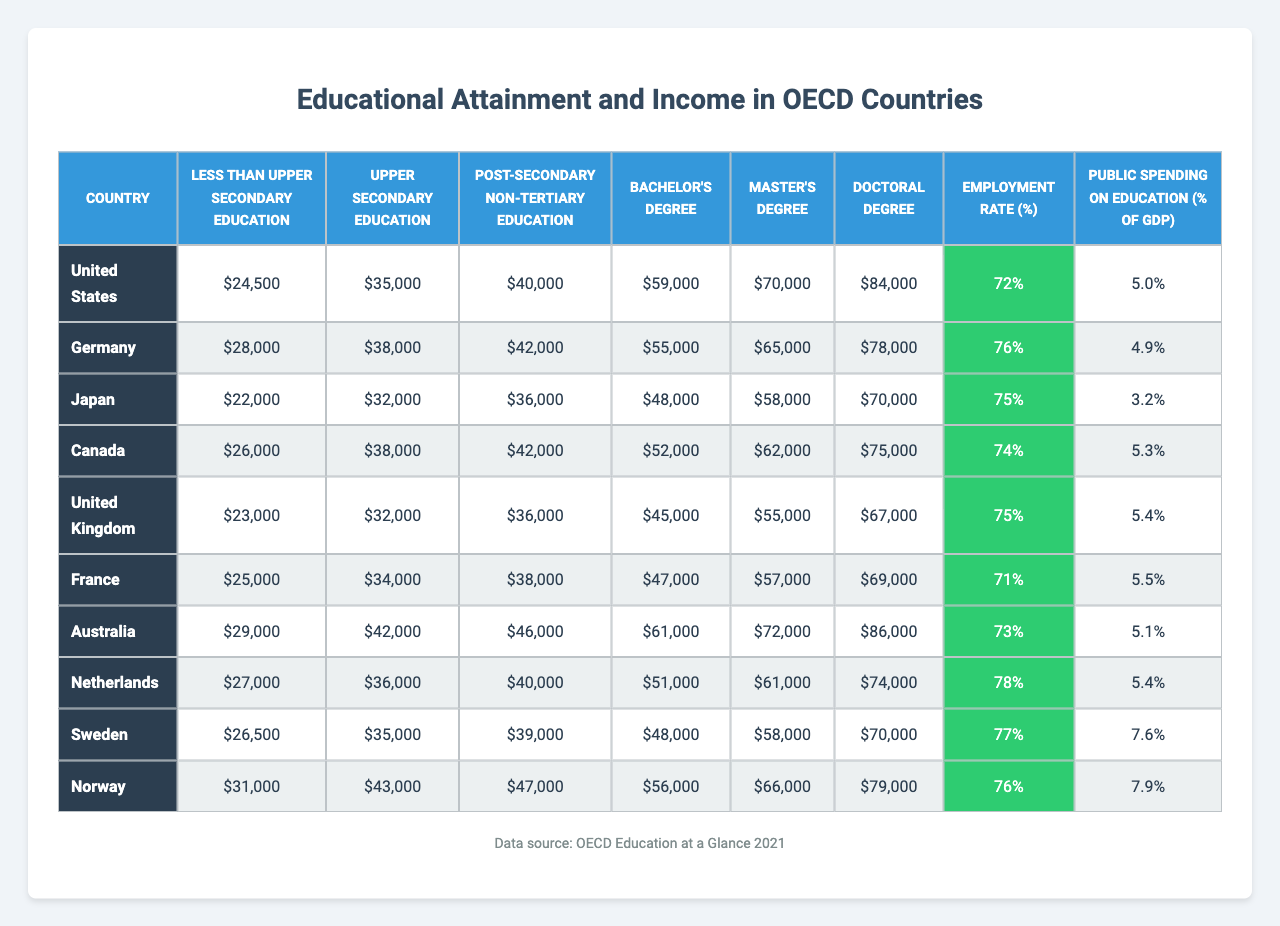What is the income for a person with a Bachelor's degree in Canada? According to the table, the income for a Bachelor's degree holder in Canada is specified as $52,000.
Answer: $52,000 Which country has the highest income for those with a Master's degree? From the table, Australia has the highest income for a Master's degree at $72,000, compared to others listed.
Answer: Australia - $72,000 What is the employment rate for the country with the least public spending on education? The country with the least public spending on education is Japan at 3.2%. The corresponding employment rate for Japan is 75%.
Answer: 75% How does the income for less than upper secondary education in the United States compare to that in Germany? The income in the United States is $24,500 and in Germany, it is $28,000. The difference is $28,000 - $24,500 = $3,500, indicating Germany has a higher income by that amount.
Answer: Germany is higher by $3,500 What is the average income for individuals with a Doctoral degree across all listed countries? To find the average, add the Doctoral degree incomes: (84,000 + 78,000 + 70,000 + 75,000 + 67,000 + 69,000 + 86,000 + 74,000 + 70,000 + 79,000) =  1,068,000, and divide by 10. The average income is $106,800 / 10 = $106,800.
Answer: $106,800 Which educational attainment level has the highest income in Sweden? The highest income in Sweden is for individuals with a Master's degree, which is $58,000.
Answer: Master's degree - $58,000 Is the employment rate higher for people with a Bachelor's degree compared to those with a Post-secondary non-tertiary education in Australia? In Australia, the employment rate for those with a Bachelor's degree is not provided, but the employment rate for Post-secondary non-tertiary education is 73%. Thus, without the Bachelor's degree figure, this comparison cannot be directly determined.
Answer: Cannot be determined What is the difference in income between a person with a Bachelor's degree and a Doctoral degree in the United Kingdom? The income for a Bachelor's degree in the United Kingdom is $45,000 and for a Doctoral degree, it's $67,000. The difference is $67,000 - $45,000 = $22,000.
Answer: $22,000 How many countries have a public spending on education greater than 5% of GDP? From the table, five countries have public spending greater than 5%: Canada (5.3%), United Kingdom (5.4%), France (5.5%), Sweden (7.6%), and Norway (7.9%).
Answer: 5 countries Which country has the highest income for individuals with upper secondary education? The highest income for upper secondary education is in Australia at $42,000, compared to other countries listed.
Answer: Australia - $42,000 